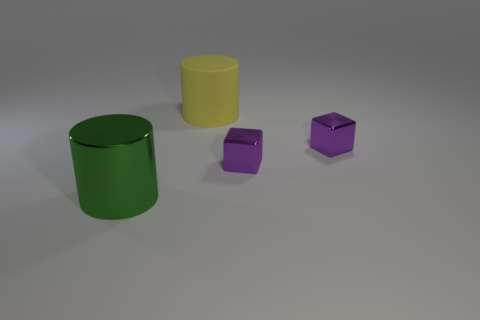Add 3 small purple shiny blocks. How many objects exist? 7 Subtract all green cylinders. How many cylinders are left? 1 Subtract 1 cylinders. How many cylinders are left? 1 Subtract all red blocks. How many yellow cylinders are left? 1 Subtract all big blue spheres. Subtract all small objects. How many objects are left? 2 Add 3 metallic cylinders. How many metallic cylinders are left? 4 Add 1 large green rubber blocks. How many large green rubber blocks exist? 1 Subtract 0 brown cubes. How many objects are left? 4 Subtract all blue cylinders. Subtract all brown spheres. How many cylinders are left? 2 